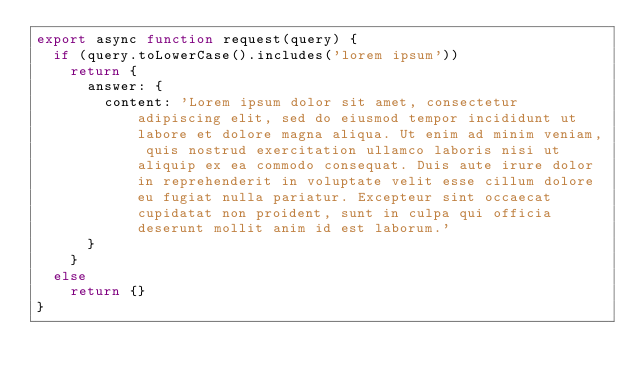<code> <loc_0><loc_0><loc_500><loc_500><_TypeScript_>export async function request(query) {
	if (query.toLowerCase().includes('lorem ipsum'))
		return {
			answer: {
				content: 'Lorem ipsum dolor sit amet, consectetur adipiscing elit, sed do eiusmod tempor incididunt ut labore et dolore magna aliqua. Ut enim ad minim veniam, quis nostrud exercitation ullamco laboris nisi ut aliquip ex ea commodo consequat. Duis aute irure dolor in reprehenderit in voluptate velit esse cillum dolore eu fugiat nulla pariatur. Excepteur sint occaecat cupidatat non proident, sunt in culpa qui officia deserunt mollit anim id est laborum.'
			}
		}
	else
		return {}
}
</code> 